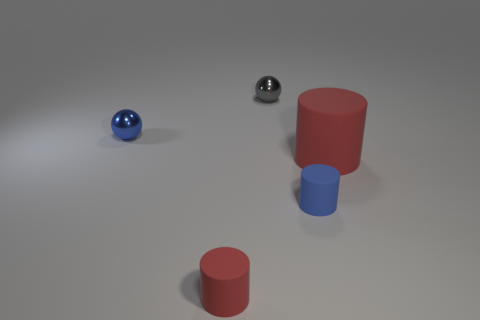What is the size of the thing that is both behind the blue rubber cylinder and in front of the tiny blue metallic object?
Offer a very short reply. Large. There is a big rubber thing; what number of tiny objects are behind it?
Make the answer very short. 2. There is a rubber object that is both left of the big red cylinder and right of the small red matte cylinder; what shape is it?
Offer a terse response. Cylinder. How many spheres are either large blue rubber objects or tiny red rubber objects?
Offer a terse response. 0. Are there fewer tiny metal objects in front of the small gray metallic thing than small blue metal spheres?
Your answer should be compact. No. What is the color of the thing that is both in front of the big red object and on the left side of the blue matte cylinder?
Your answer should be compact. Red. What number of other things are the same shape as the small gray thing?
Your answer should be compact. 1. Is the number of metal balls that are behind the small gray metallic object less than the number of small gray objects that are to the left of the tiny red thing?
Provide a short and direct response. No. Is the tiny gray sphere made of the same material as the cylinder that is in front of the blue matte object?
Offer a very short reply. No. Is the number of big red cylinders greater than the number of tiny green rubber cubes?
Provide a short and direct response. Yes. 